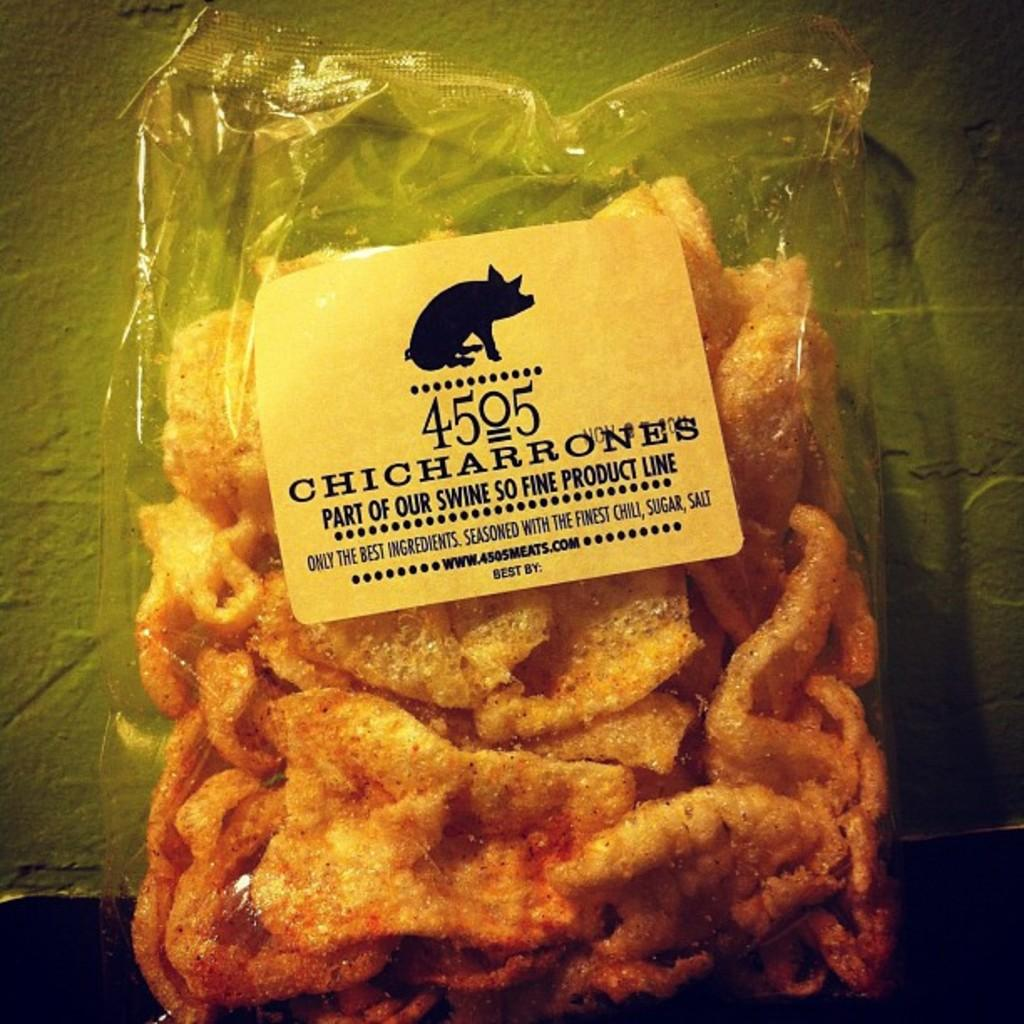What is in the image that contains food? There is a packet in the image that contains food. What can be found on the packet besides the food? The packet has a label with an image of an animal and some text. What is visible in the background of the image? There is a wall in the background of the image. How many rings are being used to open the packet in the image? There are no rings present in the image, and the packet does not need to be opened as it is already labeled. 